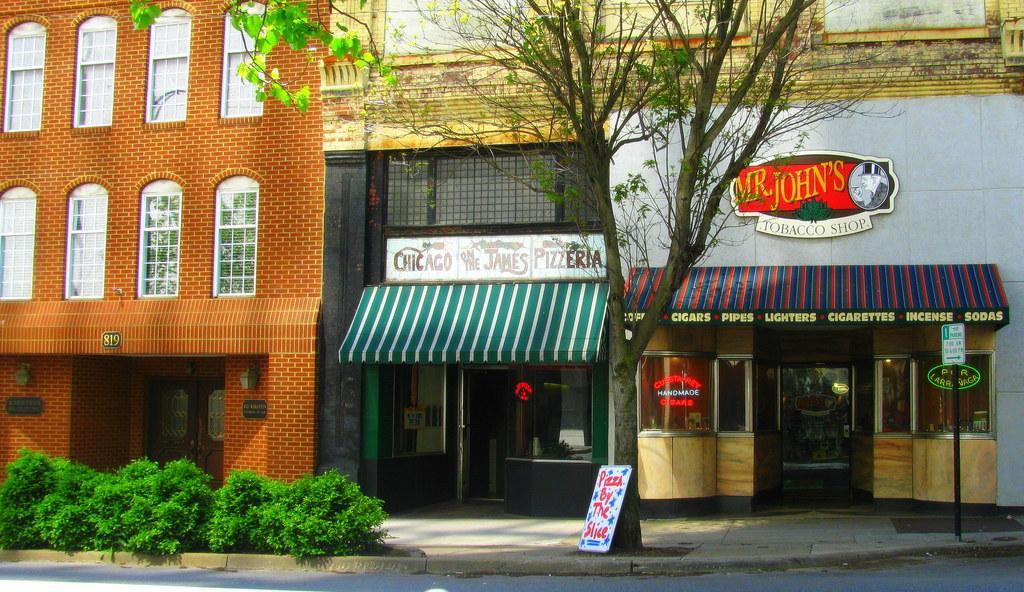How would you summarize this image in a sentence or two? This picture is clicked outside. On the left we can see the plants. In the center there is a tree and a board on which we can see the text. In the background we can see the buildings and we can see the text on the buildings. 